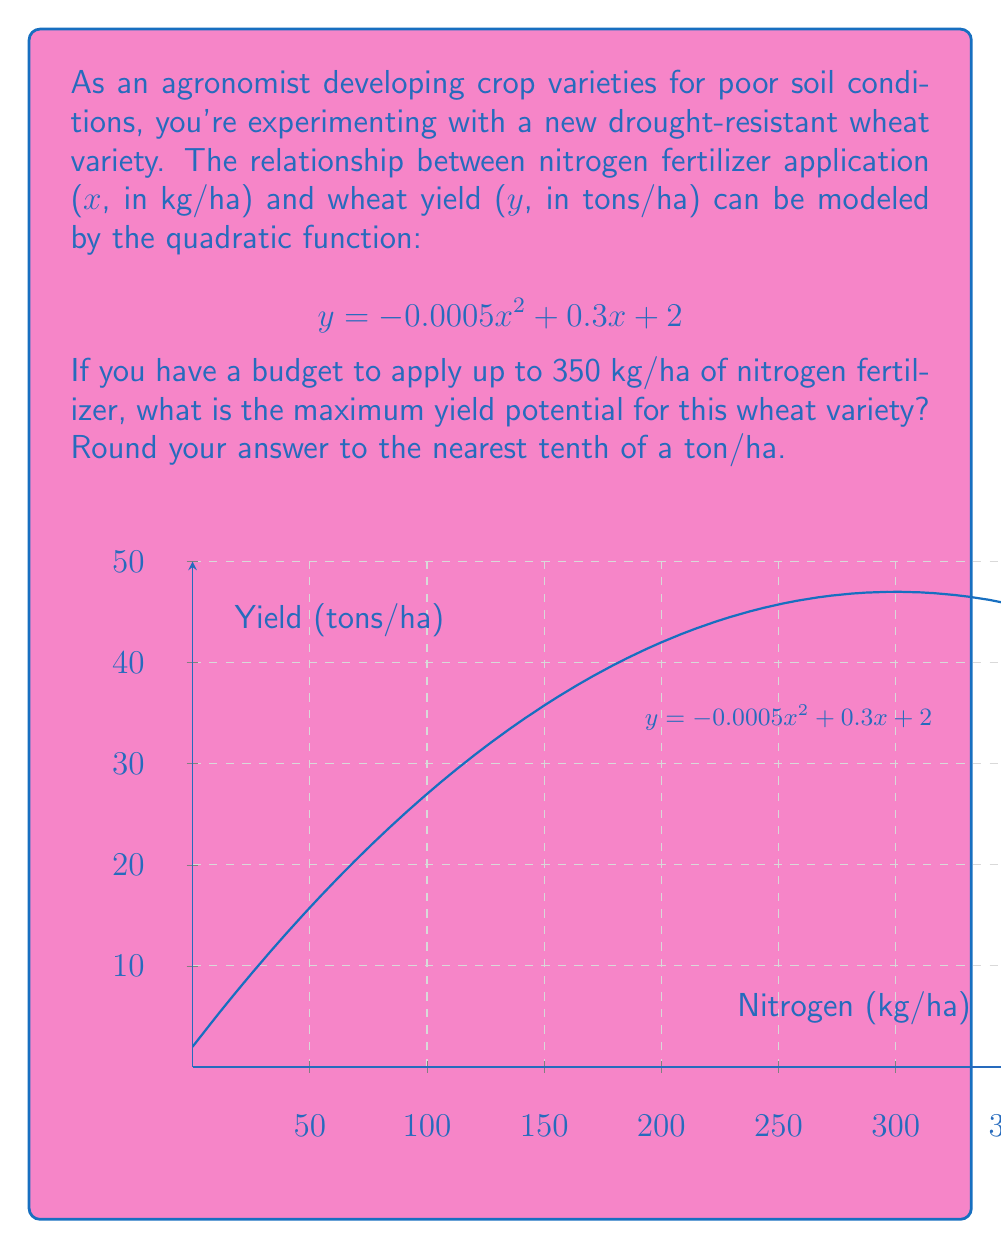Teach me how to tackle this problem. To find the maximum yield potential, we need to determine the vertex of the quadratic function. The vertex represents the point where the yield is at its maximum.

Step 1: Identify the quadratic function in standard form $y = ax^2 + bx + c$
$$y = -0.0005x^2 + 0.3x + 2$$
Here, $a = -0.0005$, $b = 0.3$, and $c = 2$

Step 2: Calculate the x-coordinate of the vertex using the formula $x = -\frac{b}{2a}$
$$x = -\frac{0.3}{2(-0.0005)} = \frac{0.3}{0.001} = 300$$

Step 3: Calculate the maximum yield by substituting x = 300 into the original function
$$y = -0.0005(300)^2 + 0.3(300) + 2$$
$$y = -0.0005(90000) + 90 + 2$$
$$y = -45 + 90 + 2$$
$$y = 47$$

Step 4: Round the result to the nearest tenth
47 rounded to the nearest tenth is 47.0 tons/ha

Therefore, the maximum yield potential for this wheat variety is 47.0 tons/ha when applying 300 kg/ha of nitrogen fertilizer.
Answer: 47.0 tons/ha 